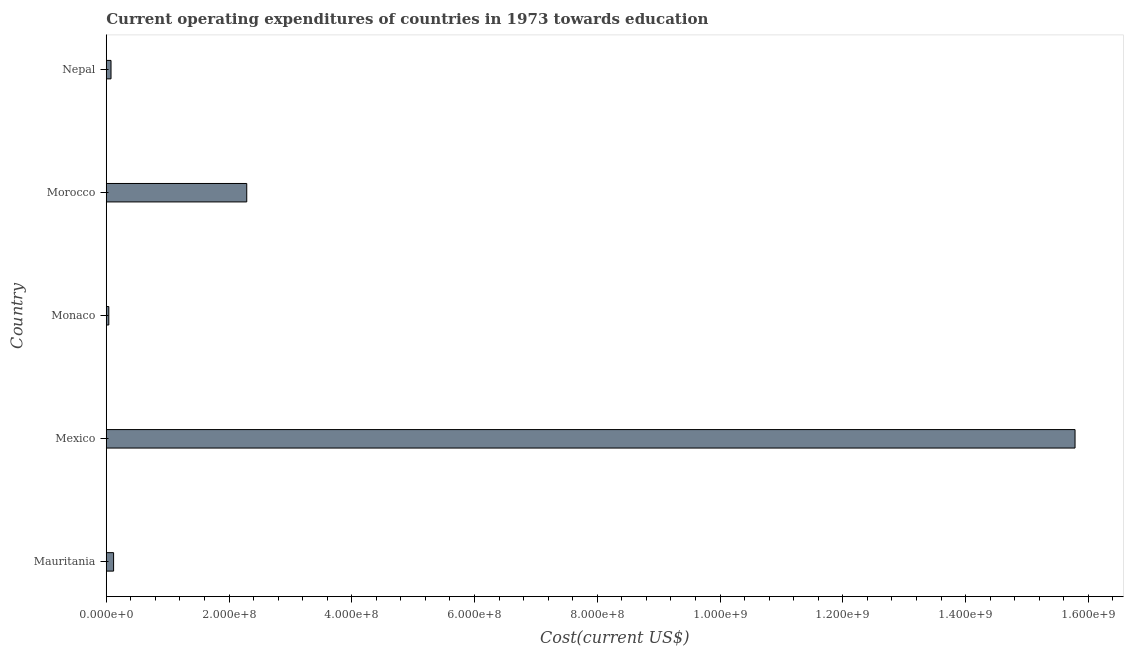Does the graph contain grids?
Keep it short and to the point. No. What is the title of the graph?
Offer a terse response. Current operating expenditures of countries in 1973 towards education. What is the label or title of the X-axis?
Offer a very short reply. Cost(current US$). What is the label or title of the Y-axis?
Your answer should be very brief. Country. What is the education expenditure in Mauritania?
Give a very brief answer. 1.20e+07. Across all countries, what is the maximum education expenditure?
Keep it short and to the point. 1.58e+09. Across all countries, what is the minimum education expenditure?
Offer a very short reply. 4.19e+06. In which country was the education expenditure minimum?
Give a very brief answer. Monaco. What is the sum of the education expenditure?
Your answer should be very brief. 1.83e+09. What is the difference between the education expenditure in Mauritania and Mexico?
Give a very brief answer. -1.57e+09. What is the average education expenditure per country?
Provide a succinct answer. 3.66e+08. What is the median education expenditure?
Your answer should be compact. 1.20e+07. What is the ratio of the education expenditure in Mauritania to that in Mexico?
Your response must be concise. 0.01. What is the difference between the highest and the second highest education expenditure?
Your response must be concise. 1.35e+09. What is the difference between the highest and the lowest education expenditure?
Offer a terse response. 1.57e+09. In how many countries, is the education expenditure greater than the average education expenditure taken over all countries?
Your answer should be very brief. 1. How many bars are there?
Make the answer very short. 5. Are all the bars in the graph horizontal?
Your response must be concise. Yes. How many countries are there in the graph?
Make the answer very short. 5. Are the values on the major ticks of X-axis written in scientific E-notation?
Your answer should be very brief. Yes. What is the Cost(current US$) of Mauritania?
Keep it short and to the point. 1.20e+07. What is the Cost(current US$) of Mexico?
Your response must be concise. 1.58e+09. What is the Cost(current US$) in Monaco?
Provide a succinct answer. 4.19e+06. What is the Cost(current US$) of Morocco?
Your response must be concise. 2.29e+08. What is the Cost(current US$) in Nepal?
Keep it short and to the point. 7.78e+06. What is the difference between the Cost(current US$) in Mauritania and Mexico?
Provide a succinct answer. -1.57e+09. What is the difference between the Cost(current US$) in Mauritania and Monaco?
Give a very brief answer. 7.79e+06. What is the difference between the Cost(current US$) in Mauritania and Morocco?
Your answer should be very brief. -2.17e+08. What is the difference between the Cost(current US$) in Mauritania and Nepal?
Provide a short and direct response. 4.20e+06. What is the difference between the Cost(current US$) in Mexico and Monaco?
Your answer should be very brief. 1.57e+09. What is the difference between the Cost(current US$) in Mexico and Morocco?
Your response must be concise. 1.35e+09. What is the difference between the Cost(current US$) in Mexico and Nepal?
Offer a very short reply. 1.57e+09. What is the difference between the Cost(current US$) in Monaco and Morocco?
Keep it short and to the point. -2.25e+08. What is the difference between the Cost(current US$) in Monaco and Nepal?
Keep it short and to the point. -3.59e+06. What is the difference between the Cost(current US$) in Morocco and Nepal?
Keep it short and to the point. 2.21e+08. What is the ratio of the Cost(current US$) in Mauritania to that in Mexico?
Provide a succinct answer. 0.01. What is the ratio of the Cost(current US$) in Mauritania to that in Monaco?
Give a very brief answer. 2.86. What is the ratio of the Cost(current US$) in Mauritania to that in Morocco?
Offer a very short reply. 0.05. What is the ratio of the Cost(current US$) in Mauritania to that in Nepal?
Your response must be concise. 1.54. What is the ratio of the Cost(current US$) in Mexico to that in Monaco?
Offer a terse response. 376.84. What is the ratio of the Cost(current US$) in Mexico to that in Morocco?
Make the answer very short. 6.89. What is the ratio of the Cost(current US$) in Mexico to that in Nepal?
Ensure brevity in your answer.  202.96. What is the ratio of the Cost(current US$) in Monaco to that in Morocco?
Ensure brevity in your answer.  0.02. What is the ratio of the Cost(current US$) in Monaco to that in Nepal?
Offer a terse response. 0.54. What is the ratio of the Cost(current US$) in Morocco to that in Nepal?
Give a very brief answer. 29.43. 